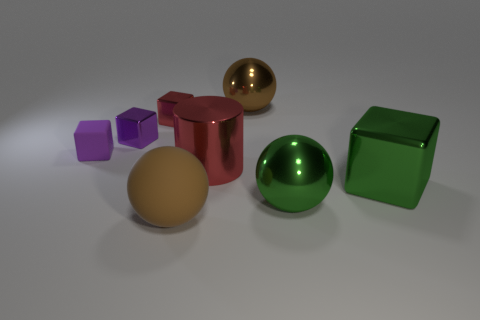Is there anything else that is the same shape as the purple rubber object?
Offer a terse response. Yes. Is the number of tiny red objects to the left of the purple metallic thing the same as the number of small purple metal cubes?
Your answer should be very brief. No. Do the rubber ball and the shiny thing that is in front of the large green shiny block have the same color?
Offer a very short reply. No. There is a sphere that is in front of the big green metal cube and to the right of the big brown rubber object; what color is it?
Your answer should be compact. Green. How many large green shiny spheres are in front of the metallic ball in front of the large brown shiny object?
Ensure brevity in your answer.  0. Is there a tiny red object that has the same shape as the purple shiny thing?
Give a very brief answer. Yes. There is a big brown thing that is in front of the large brown metal object; is its shape the same as the brown thing that is right of the big red object?
Your answer should be very brief. Yes. How many things are purple objects or blue shiny balls?
Your answer should be compact. 2. There is another purple object that is the same shape as the purple metallic object; what size is it?
Make the answer very short. Small. Is the number of objects to the right of the green shiny ball greater than the number of big purple cylinders?
Give a very brief answer. Yes. 